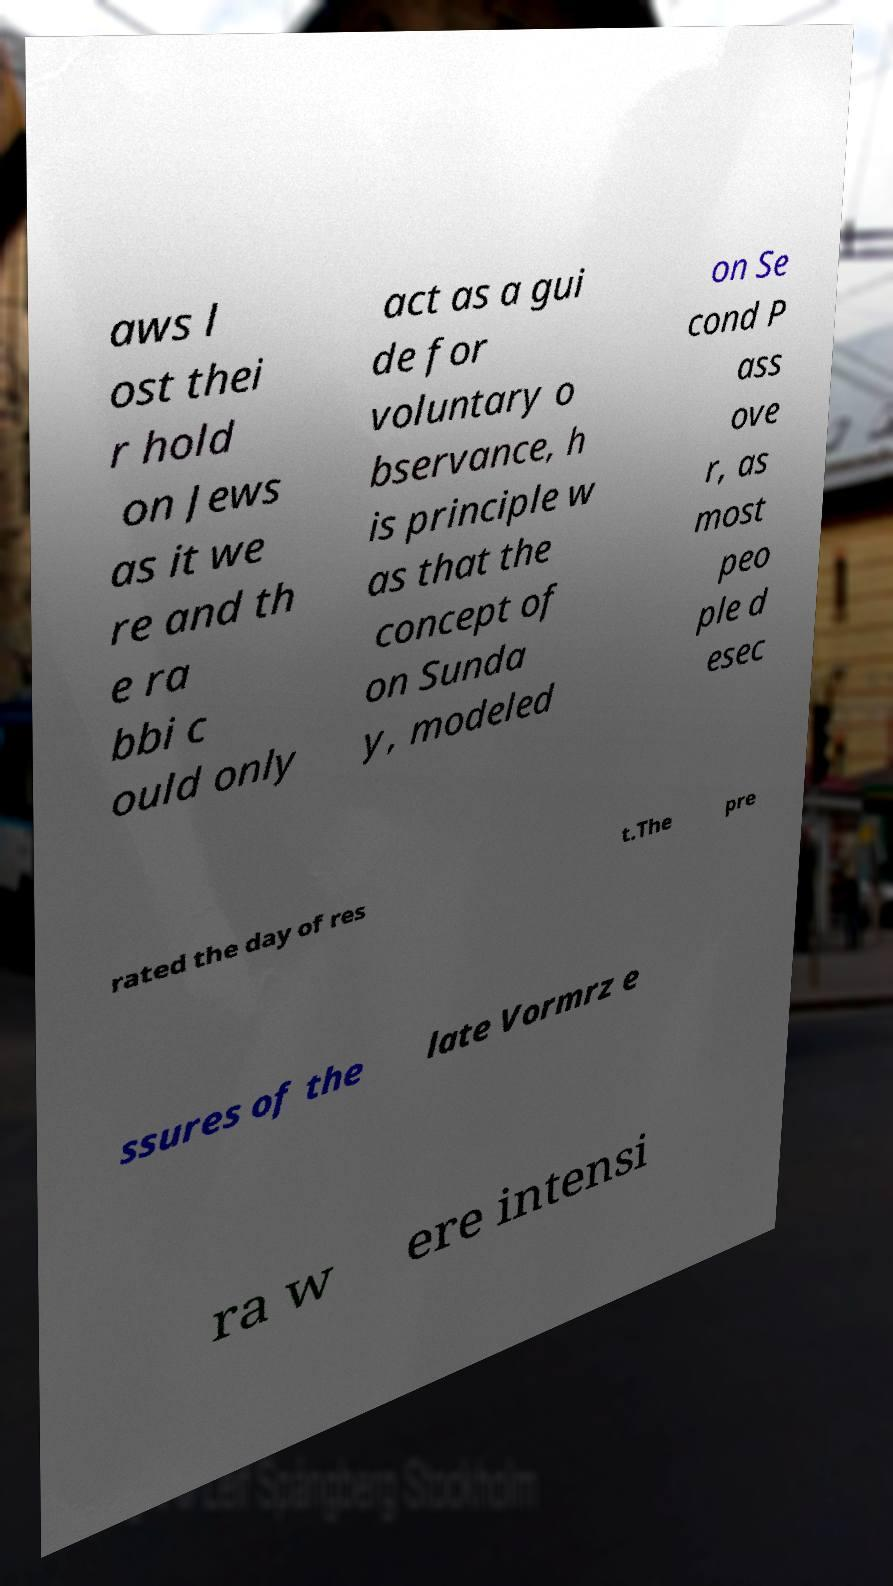For documentation purposes, I need the text within this image transcribed. Could you provide that? aws l ost thei r hold on Jews as it we re and th e ra bbi c ould only act as a gui de for voluntary o bservance, h is principle w as that the concept of on Sunda y, modeled on Se cond P ass ove r, as most peo ple d esec rated the day of res t.The pre ssures of the late Vormrz e ra w ere intensi 